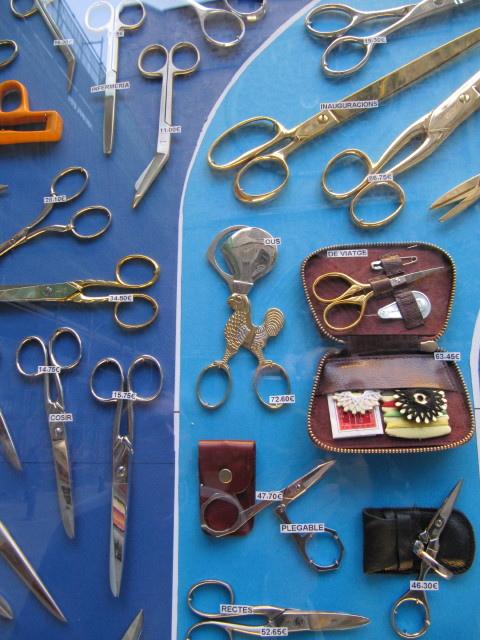Is this a collection of knives?
Answer briefly. No. What are these items all made of?
Give a very brief answer. Metal. What are these objects used for?
Answer briefly. Cutting. 